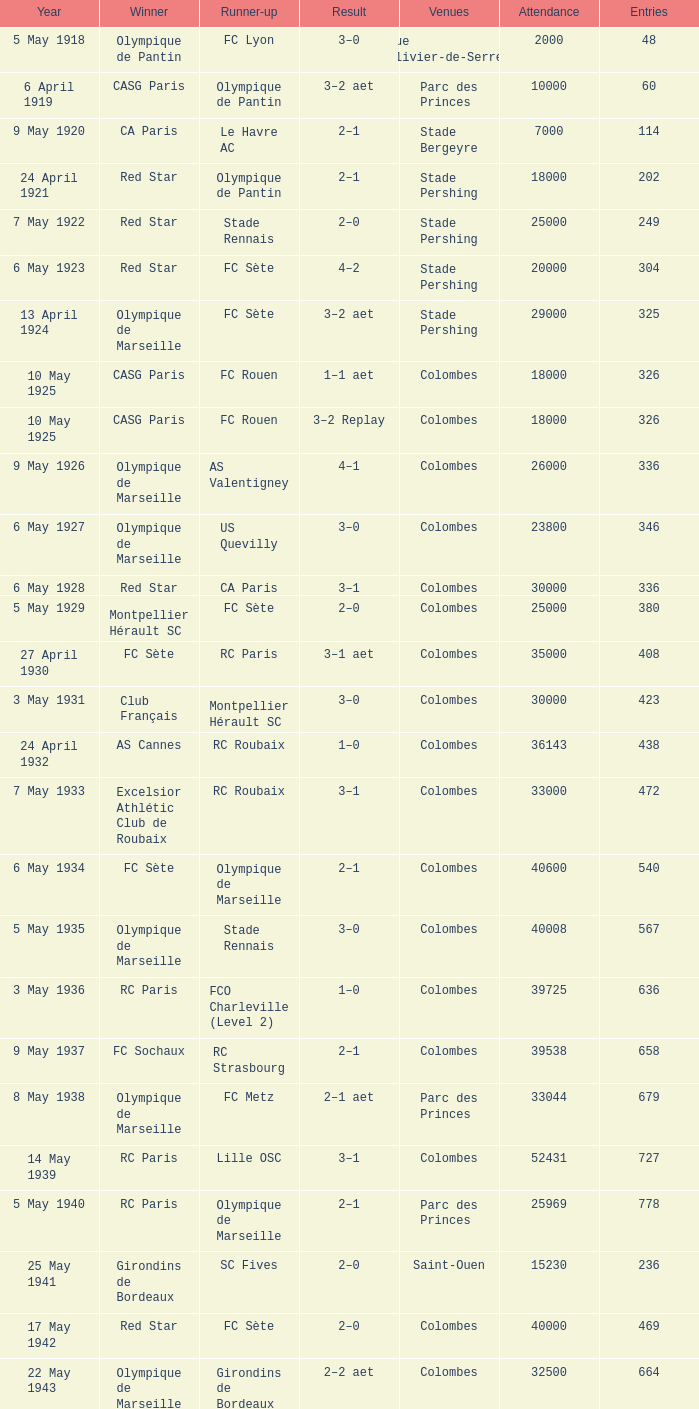How many contests had red star as the second place finisher? 1.0. 